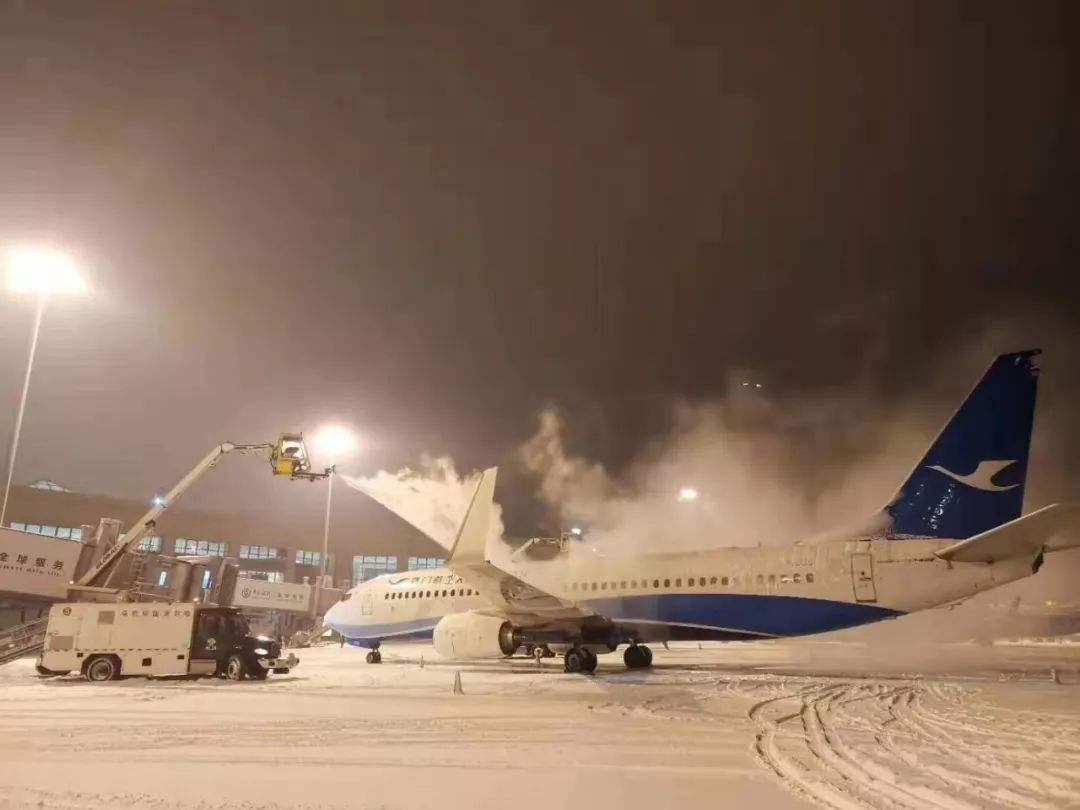Can you describe the weather conditions visible in the image? The weather appears to be cold and snowy, as evidenced by the presence of snow on the ground and the operation of de-icing equipment. The visibility is decreased due to the presence of snow or ice particles in the air, suggesting an active snowfall or blowing snow. 